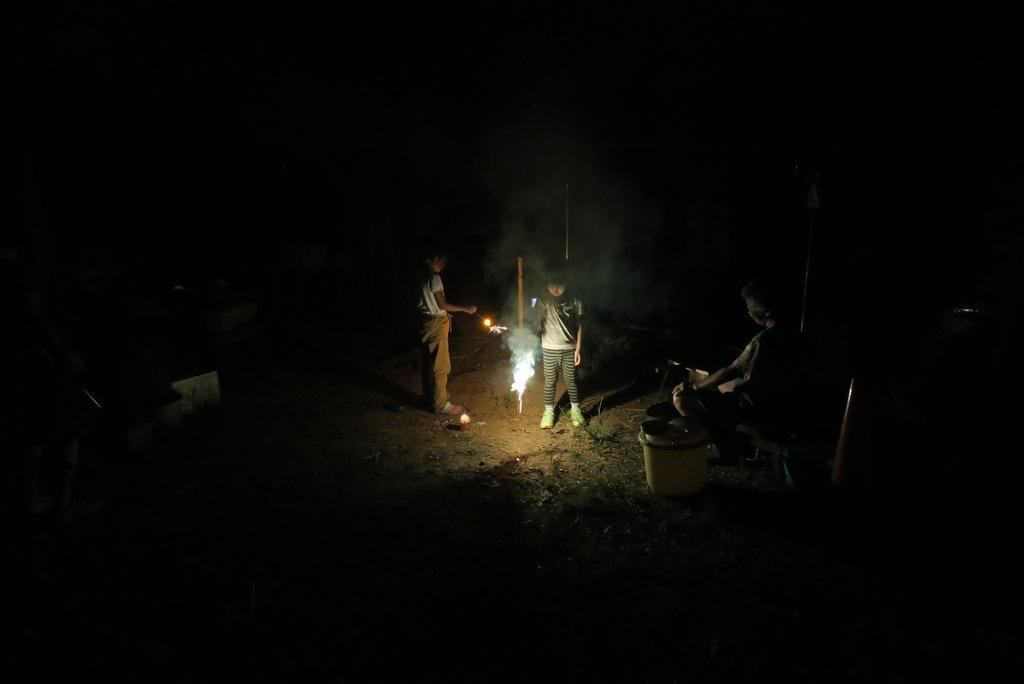What are the people in the image doing? The people in the image are standing. Is there anyone sitting in the image? Yes, there is a person sitting on a chair in the image. What can be seen in the sky in the image? Fireworks are visible in the image. What type of rod is being used by the mother in the image? There is no mother or rod present in the image. What scene is depicted in the image? The image depicts people standing and one person sitting, with fireworks visible in the sky. 